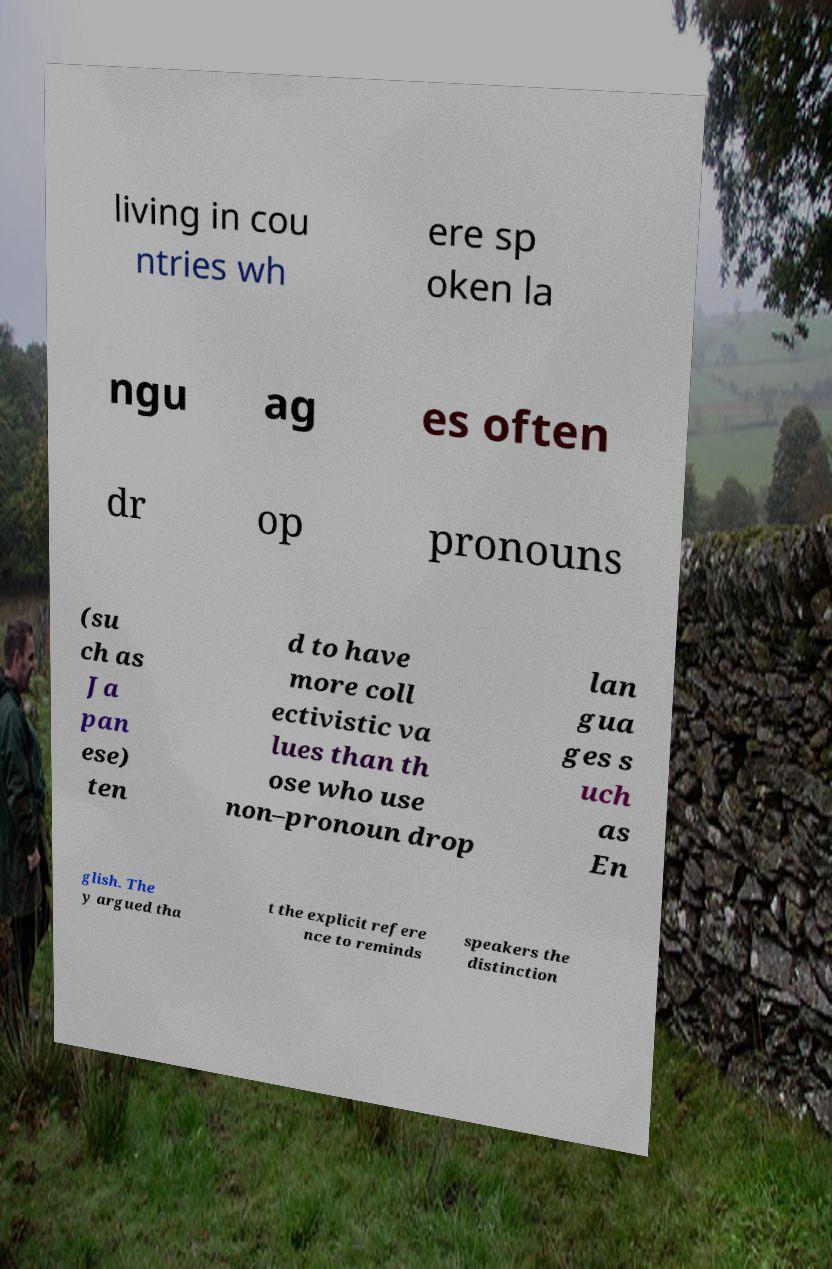What messages or text are displayed in this image? I need them in a readable, typed format. living in cou ntries wh ere sp oken la ngu ag es often dr op pronouns (su ch as Ja pan ese) ten d to have more coll ectivistic va lues than th ose who use non–pronoun drop lan gua ges s uch as En glish. The y argued tha t the explicit refere nce to reminds speakers the distinction 